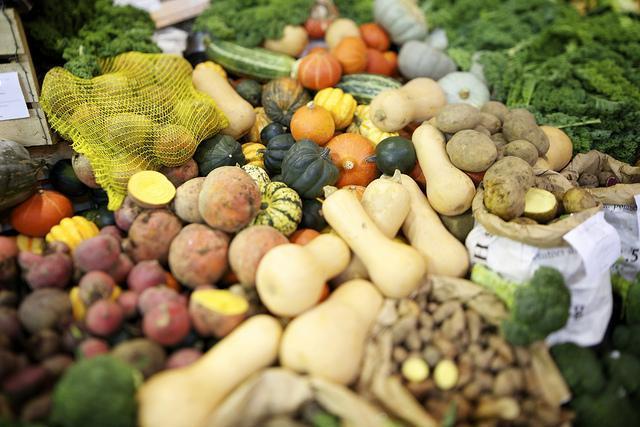How many broccolis are in the photo?
Give a very brief answer. 8. 